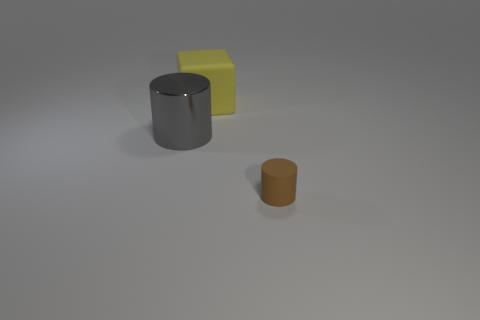Subtract all gray cylinders. How many cylinders are left? 1 Add 1 big yellow matte things. How many objects exist? 4 Subtract all cylinders. How many objects are left? 1 Subtract 1 cubes. How many cubes are left? 0 Subtract all small gray metal cylinders. Subtract all large yellow matte blocks. How many objects are left? 2 Add 3 yellow cubes. How many yellow cubes are left? 4 Add 3 matte objects. How many matte objects exist? 5 Subtract 0 red cylinders. How many objects are left? 3 Subtract all purple cubes. Subtract all gray cylinders. How many cubes are left? 1 Subtract all yellow balls. How many red blocks are left? 0 